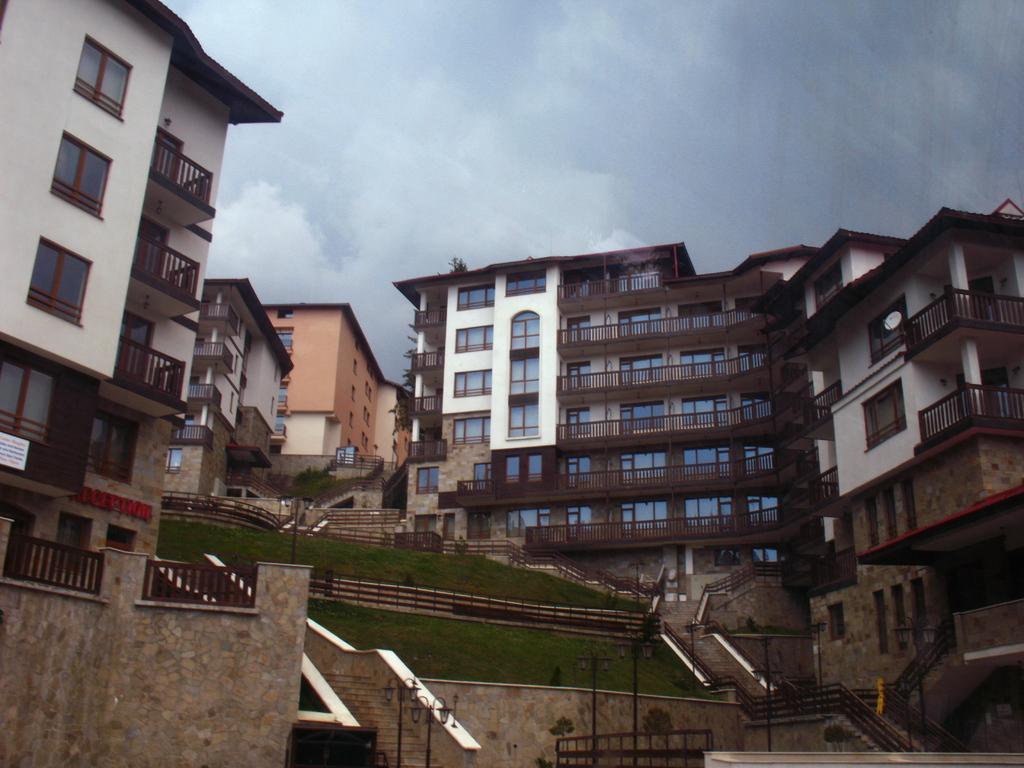Could you give a brief overview of what you see in this image? In this image I can see the buildings which are in white and brown color. In-front of the building I can see the stairs and railing. I can also see the poles. In the back there are clouds and the sky. 